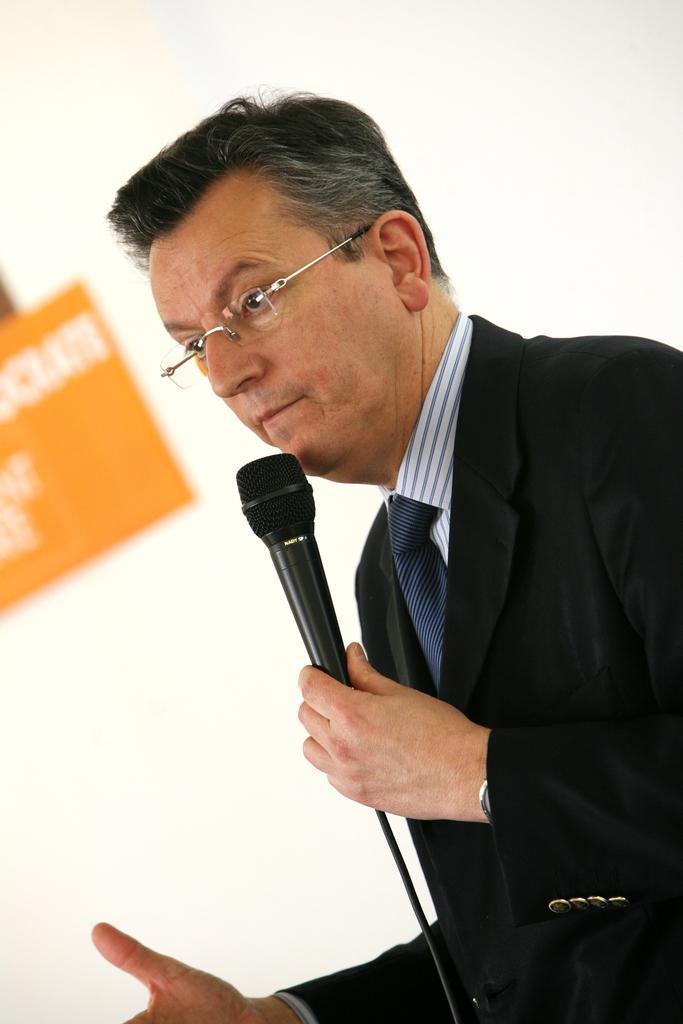Could you give a brief overview of what you see in this image? In the image there is a man holding a microphone and he is also wearing a black color suit, in background we can see hoardings. 